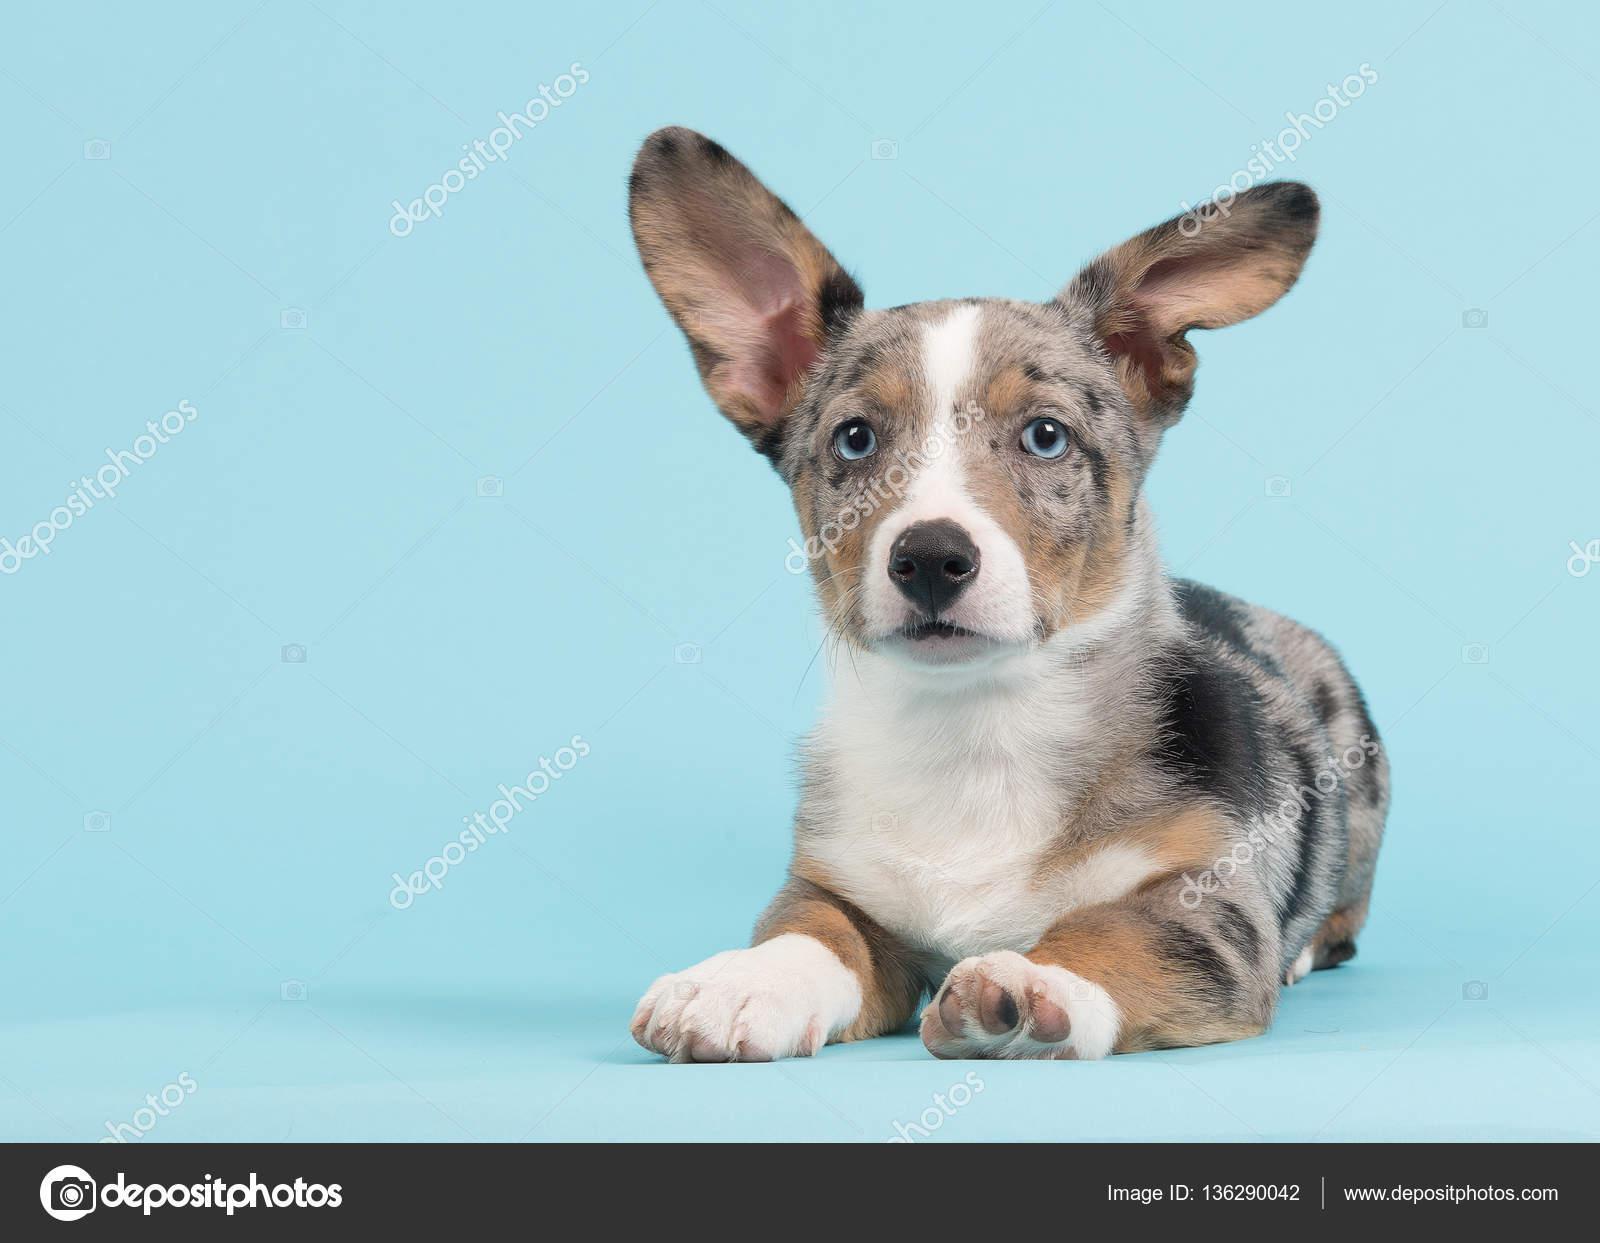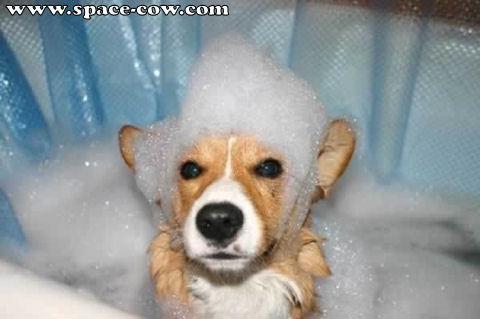The first image is the image on the left, the second image is the image on the right. Examine the images to the left and right. Is the description "One of the images shows a corgi sitting on the ground outside with its entire body visible." accurate? Answer yes or no. No. 